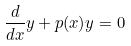<formula> <loc_0><loc_0><loc_500><loc_500>\frac { d } { d x } y + p ( x ) y = 0</formula> 